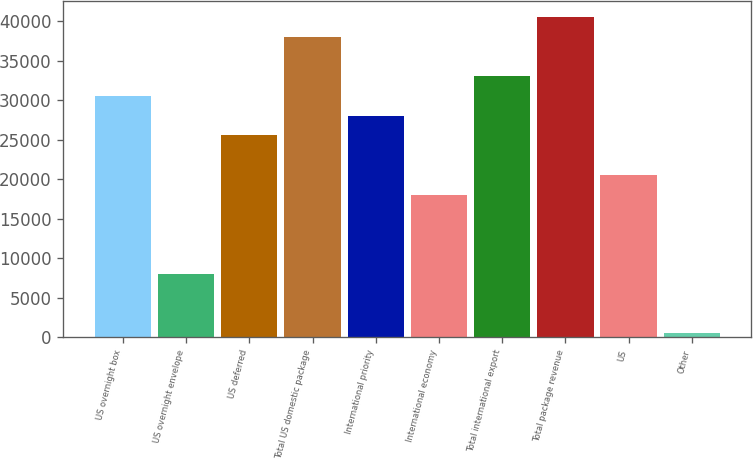Convert chart. <chart><loc_0><loc_0><loc_500><loc_500><bar_chart><fcel>US overnight box<fcel>US overnight envelope<fcel>US deferred<fcel>Total US domestic package<fcel>International priority<fcel>International economy<fcel>Total international export<fcel>Total package revenue<fcel>US<fcel>Other<nl><fcel>30564.8<fcel>8011.7<fcel>25553<fcel>38082.5<fcel>28058.9<fcel>18035.3<fcel>33070.7<fcel>40588.4<fcel>20541.2<fcel>494<nl></chart> 